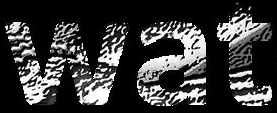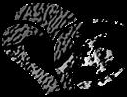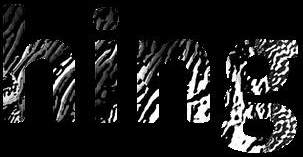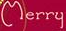Read the text from these images in sequence, separated by a semicolon. wat; #; hing; Merry 